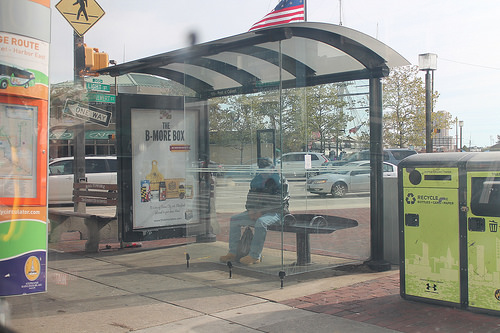<image>
Is the person in the glass? Yes. The person is contained within or inside the glass, showing a containment relationship. 